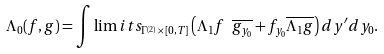Convert formula to latex. <formula><loc_0><loc_0><loc_500><loc_500>\Lambda _ { 0 } ( f , g ) = \int \lim i t s _ { \Gamma ^ { ( 2 ) } \times [ 0 , T ] } \left ( \Lambda _ { 1 } f \ \overline { g _ { y _ { 0 } } } + f _ { y _ { 0 } } \overline { \Lambda _ { 1 } g } \right ) d y ^ { \prime } d y _ { 0 } .</formula> 